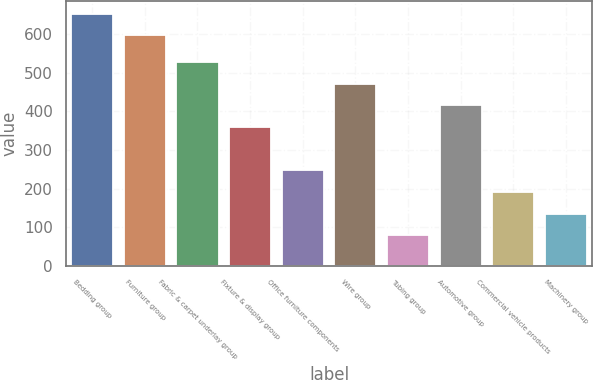<chart> <loc_0><loc_0><loc_500><loc_500><bar_chart><fcel>Bedding group<fcel>Furniture group<fcel>Fabric & carpet underlay group<fcel>Fixture & display group<fcel>Office furniture components<fcel>Wire group<fcel>Tubing group<fcel>Automotive group<fcel>Commercial vehicle products<fcel>Machinery group<nl><fcel>652.7<fcel>596.8<fcel>527.9<fcel>360.2<fcel>247.3<fcel>472<fcel>79.6<fcel>416.1<fcel>191.4<fcel>135.5<nl></chart> 